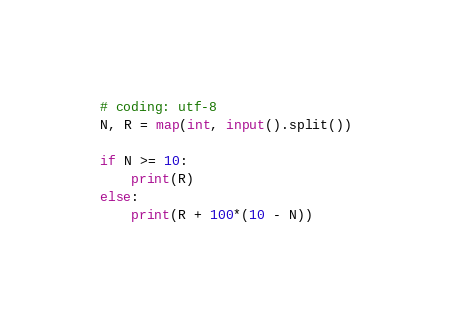Convert code to text. <code><loc_0><loc_0><loc_500><loc_500><_Python_># coding: utf-8
N, R = map(int, input().split())

if N >= 10:
    print(R)
else:
    print(R + 100*(10 - N))</code> 